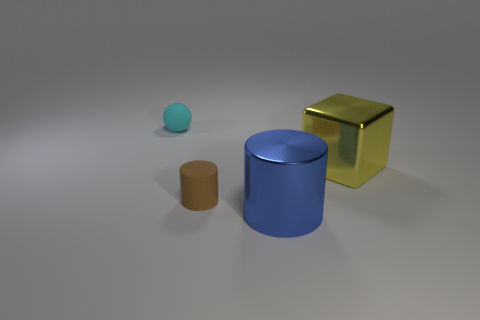Add 4 big blue cylinders. How many objects exist? 8 Subtract all blocks. How many objects are left? 3 Add 1 small things. How many small things are left? 3 Add 2 green balls. How many green balls exist? 2 Subtract 1 cyan spheres. How many objects are left? 3 Subtract all tiny purple shiny things. Subtract all blue objects. How many objects are left? 3 